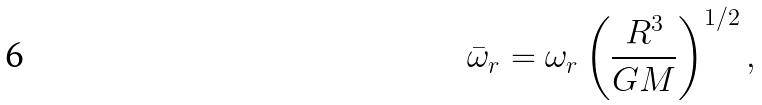Convert formula to latex. <formula><loc_0><loc_0><loc_500><loc_500>\bar { \omega } _ { r } = \omega _ { r } \left ( \frac { R ^ { 3 } } { G M } \right ) ^ { 1 / 2 } ,</formula> 